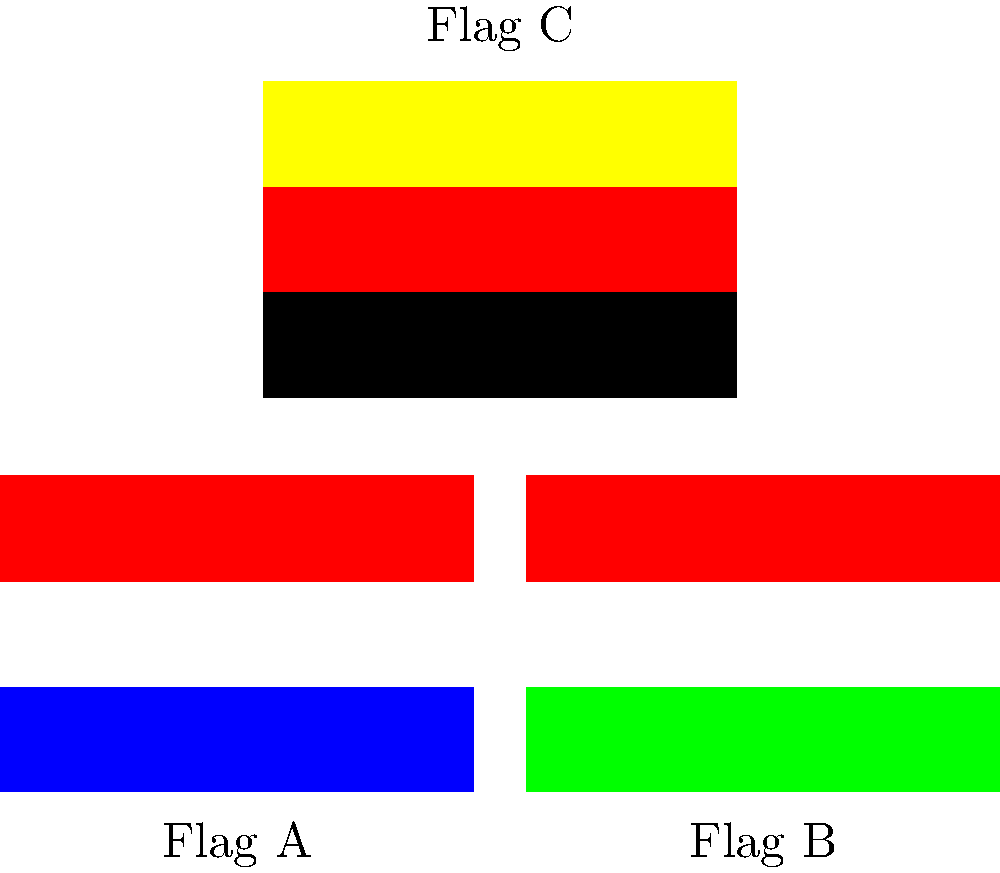In an image recognition system for classifying international flags, which feature extraction technique would be most effective in distinguishing between the flags shown, particularly for Flag C (Germany) with its unique horizontal tricolor pattern? To effectively distinguish between the flags shown, especially Flag C (Germany), we need to consider the following steps in feature extraction:

1. Color Analysis:
   - All flags use different color combinations
   - Flag C (Germany) uniquely uses black, red, and yellow

2. Pattern Recognition:
   - All flags have horizontal stripes
   - The order and width of stripes are crucial

3. Edge Detection:
   - Horizontal edges between color transitions are important
   - No vertical edges in these flags

4. Histogram of Oriented Gradients (HOG):
   - Would capture the horizontal stripe structure
   - Less effective for these particular flags due to similar layouts

5. Color Histograms:
   - Would effectively capture the unique color distributions
   - Especially useful for distinguishing Flag C's black-red-yellow combination

6. Spatial Color Distribution:
   - Captures both color and its position in the image
   - Critical for distinguishing the order of colors (e.g., blue-white-red vs. red-white-blue)

Given these considerations, the most effective feature extraction technique would be Spatial Color Distribution. This method would capture both the unique colors of Flag C (Germany) and their specific order (black-red-yellow from top to bottom), which is crucial for distinguishing it from other tricolor flags.
Answer: Spatial Color Distribution 